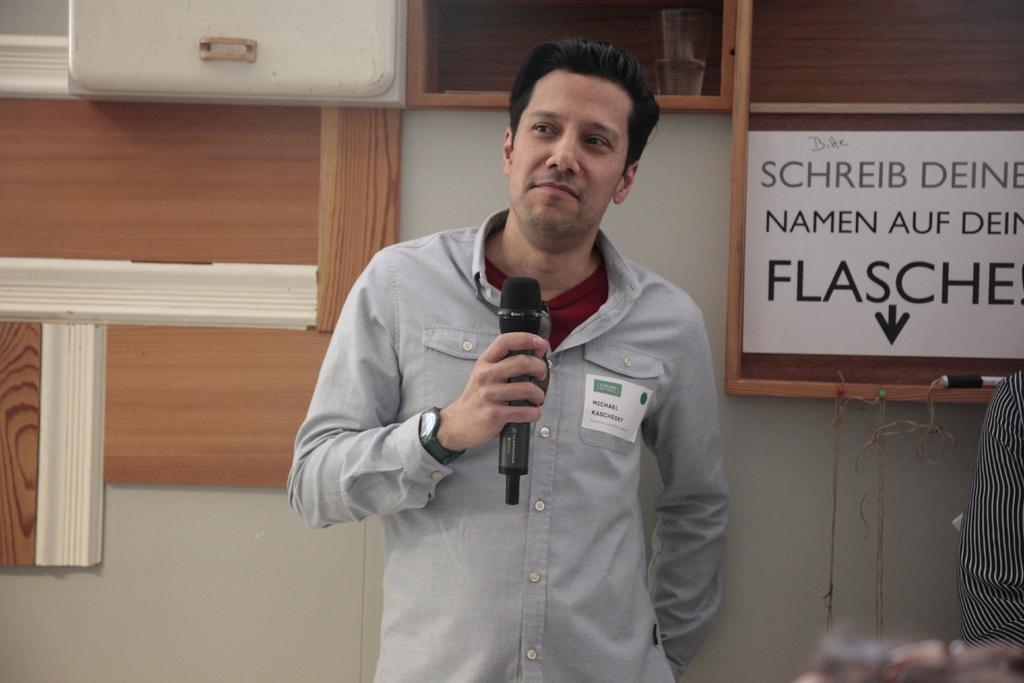Who is present in the image? There is a man in the image. What is the man holding in the image? The man is holding a mic. What expression does the man have in the image? The man is smiling. What can be seen in the background of the image? There is a wall and a board in the background of the image. How many oranges are on the board in the image? There are no oranges present in the image. Is there a birthday celebration happening in the image? There is no indication of a birthday celebration in the image. 